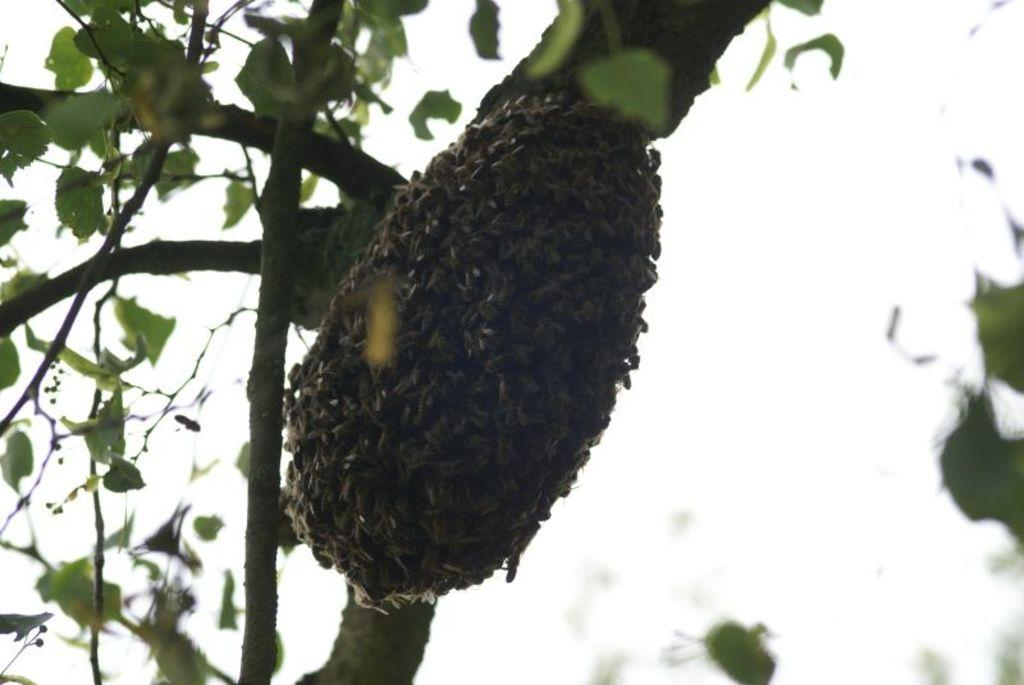What type of insects can be seen in the image? There are honey bees in the image. What is the main object in the background of the image? There is a tree in the image. What part of the tree is visible in the image? There are leaves in the image. What is visible above the tree in the image? The sky is visible in the image. What type of breakfast is being served with a fork in the image? There is no breakfast or fork present in the image; it features honey bees and a tree. 